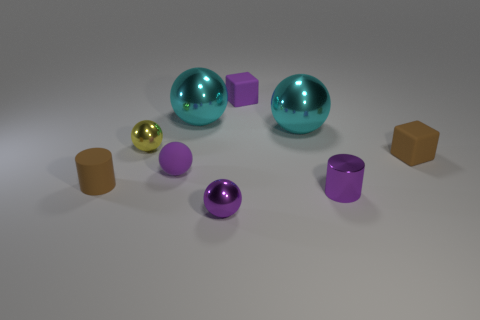Subtract all yellow spheres. How many spheres are left? 4 Subtract all small matte balls. How many balls are left? 4 Subtract all green balls. Subtract all green cylinders. How many balls are left? 5 Add 1 large green blocks. How many objects exist? 10 Subtract all spheres. How many objects are left? 4 Add 4 cyan metal objects. How many cyan metal objects are left? 6 Add 2 small metal things. How many small metal things exist? 5 Subtract 0 red spheres. How many objects are left? 9 Subtract all tiny matte blocks. Subtract all yellow balls. How many objects are left? 6 